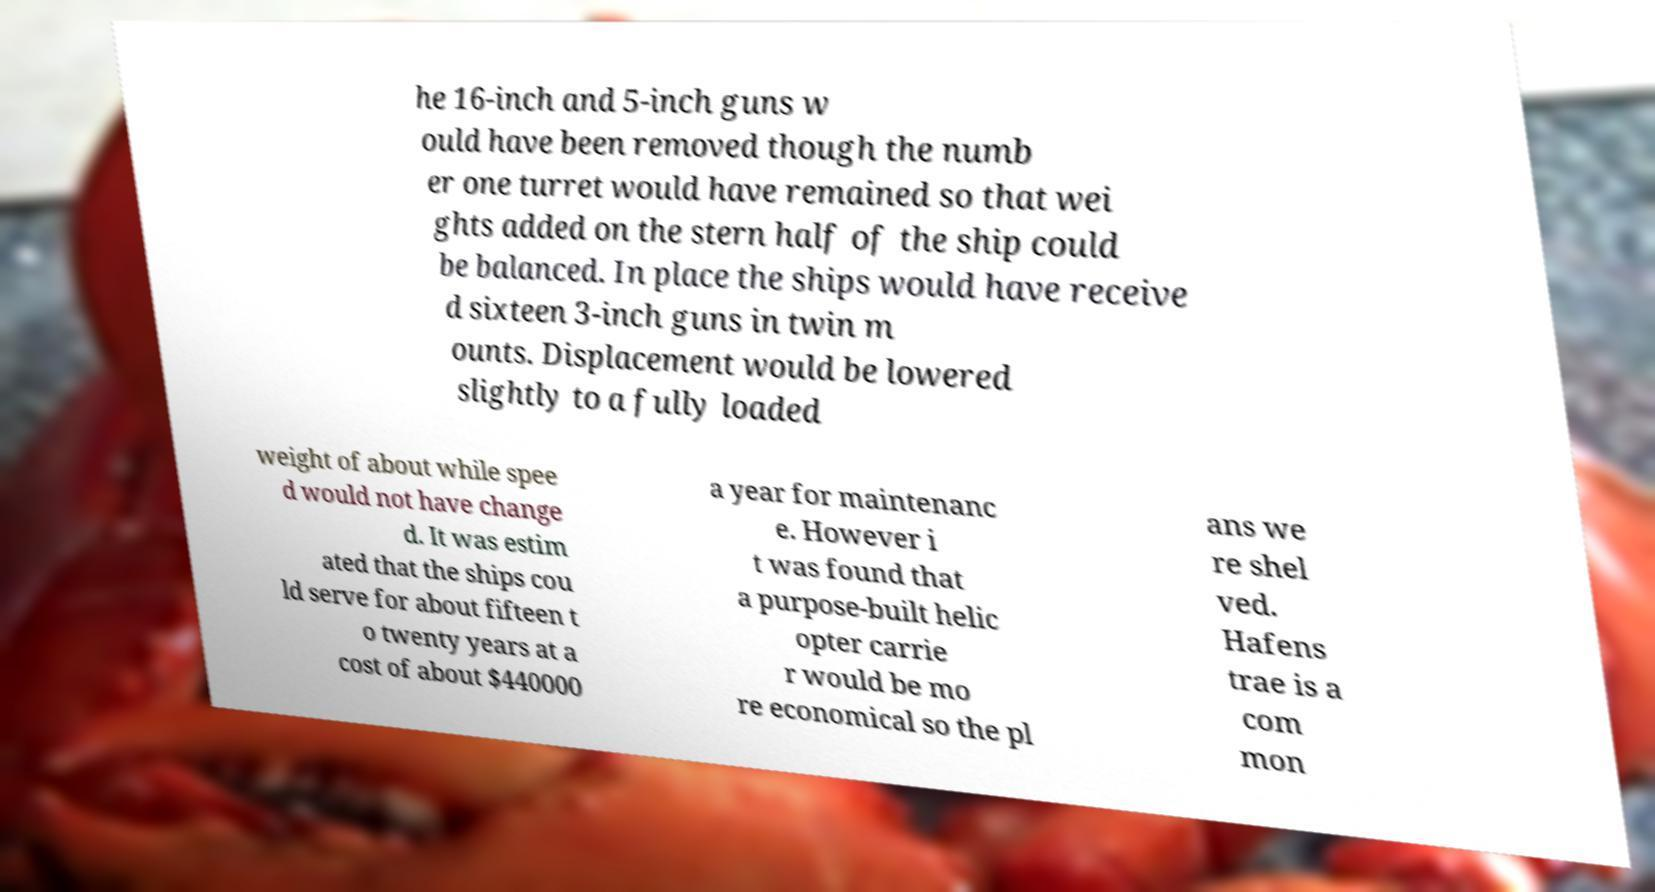I need the written content from this picture converted into text. Can you do that? he 16-inch and 5-inch guns w ould have been removed though the numb er one turret would have remained so that wei ghts added on the stern half of the ship could be balanced. In place the ships would have receive d sixteen 3-inch guns in twin m ounts. Displacement would be lowered slightly to a fully loaded weight of about while spee d would not have change d. It was estim ated that the ships cou ld serve for about fifteen t o twenty years at a cost of about $440000 a year for maintenanc e. However i t was found that a purpose-built helic opter carrie r would be mo re economical so the pl ans we re shel ved. Hafens trae is a com mon 